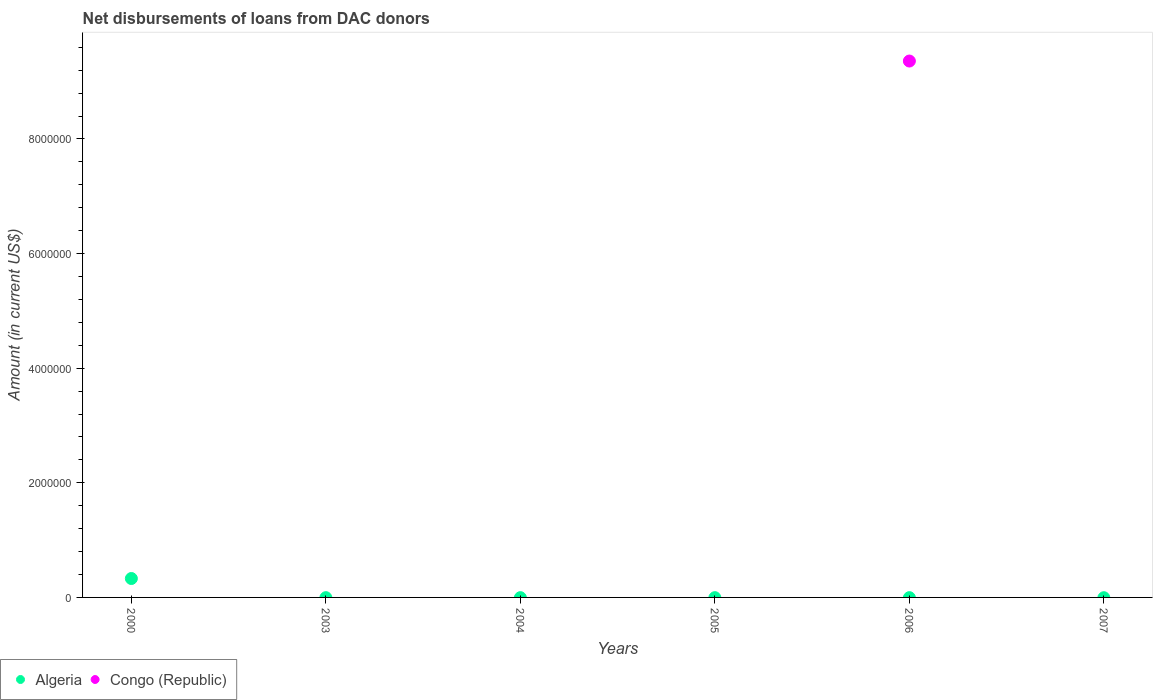How many different coloured dotlines are there?
Your answer should be compact. 2. Is the number of dotlines equal to the number of legend labels?
Your answer should be very brief. No. What is the amount of loans disbursed in Algeria in 2000?
Give a very brief answer. 3.30e+05. Across all years, what is the maximum amount of loans disbursed in Algeria?
Provide a succinct answer. 3.30e+05. What is the total amount of loans disbursed in Congo (Republic) in the graph?
Give a very brief answer. 9.36e+06. What is the difference between the amount of loans disbursed in Congo (Republic) in 2004 and the amount of loans disbursed in Algeria in 2000?
Provide a short and direct response. -3.30e+05. What is the average amount of loans disbursed in Algeria per year?
Your answer should be compact. 5.50e+04. What is the difference between the highest and the lowest amount of loans disbursed in Congo (Republic)?
Offer a very short reply. 9.36e+06. In how many years, is the amount of loans disbursed in Algeria greater than the average amount of loans disbursed in Algeria taken over all years?
Provide a short and direct response. 1. Does the amount of loans disbursed in Congo (Republic) monotonically increase over the years?
Provide a short and direct response. No. Is the amount of loans disbursed in Congo (Republic) strictly greater than the amount of loans disbursed in Algeria over the years?
Provide a short and direct response. No. How many dotlines are there?
Ensure brevity in your answer.  2. How many years are there in the graph?
Give a very brief answer. 6. What is the title of the graph?
Provide a succinct answer. Net disbursements of loans from DAC donors. Does "Virgin Islands" appear as one of the legend labels in the graph?
Keep it short and to the point. No. What is the label or title of the X-axis?
Your answer should be compact. Years. What is the label or title of the Y-axis?
Ensure brevity in your answer.  Amount (in current US$). What is the Amount (in current US$) of Congo (Republic) in 2000?
Your answer should be very brief. 0. What is the Amount (in current US$) in Algeria in 2003?
Offer a very short reply. 0. What is the Amount (in current US$) in Congo (Republic) in 2003?
Give a very brief answer. 0. What is the Amount (in current US$) of Congo (Republic) in 2004?
Your answer should be compact. 0. What is the Amount (in current US$) in Algeria in 2005?
Your answer should be very brief. 0. What is the Amount (in current US$) of Algeria in 2006?
Offer a very short reply. 0. What is the Amount (in current US$) of Congo (Republic) in 2006?
Make the answer very short. 9.36e+06. What is the Amount (in current US$) of Congo (Republic) in 2007?
Offer a terse response. 0. Across all years, what is the maximum Amount (in current US$) of Algeria?
Offer a terse response. 3.30e+05. Across all years, what is the maximum Amount (in current US$) of Congo (Republic)?
Keep it short and to the point. 9.36e+06. What is the total Amount (in current US$) of Congo (Republic) in the graph?
Give a very brief answer. 9.36e+06. What is the difference between the Amount (in current US$) in Algeria in 2000 and the Amount (in current US$) in Congo (Republic) in 2006?
Make the answer very short. -9.03e+06. What is the average Amount (in current US$) of Algeria per year?
Your answer should be very brief. 5.50e+04. What is the average Amount (in current US$) of Congo (Republic) per year?
Provide a short and direct response. 1.56e+06. What is the difference between the highest and the lowest Amount (in current US$) in Algeria?
Ensure brevity in your answer.  3.30e+05. What is the difference between the highest and the lowest Amount (in current US$) of Congo (Republic)?
Make the answer very short. 9.36e+06. 